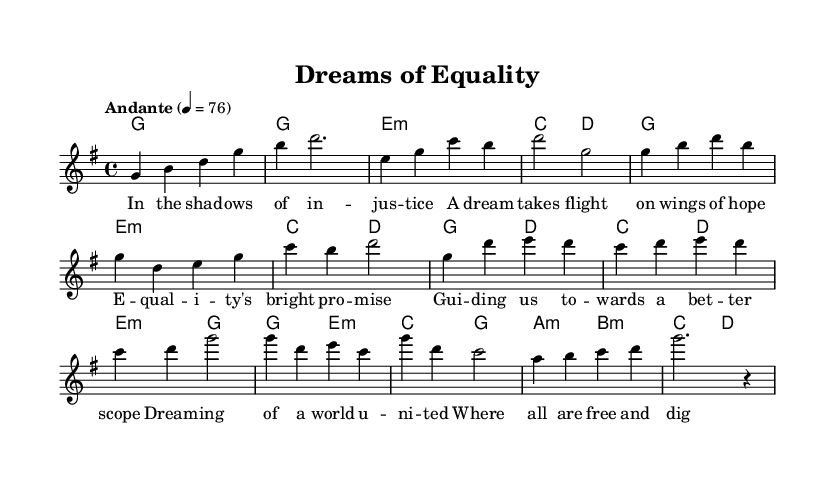What is the key signature of this music? The key signature is G major, which has one sharp (F#).
Answer: G major What is the time signature of this music? The time signature is 4/4, indicating four beats per measure.
Answer: 4/4 What is the tempo marking of the music? The tempo marking is "Andante," which generally indicates a moderate walking pace.
Answer: Andante How many measures are in the chorus section? The chorus consists of four measures, identified by distinct harmony and lyrics.
Answer: Four measures What is the main theme of the verse lyrics? The verse lyrics convey themes of justice, hope, and the pursuit of equality, reflecting on social issues.
Answer: Justice and hope What are the first two chords used in the introduction? The first two chords are G major followed by E minor, setting the tone for the piece.
Answer: G major, E minor How does the melody change in the pre-chorus compared to the verse? The melody moves upward in pitch, creating a sense of build-up and anticipation leading into the chorus.
Answer: Upward movement 